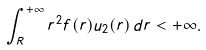<formula> <loc_0><loc_0><loc_500><loc_500>\int _ { R } ^ { + \infty } r ^ { 2 } f ( r ) u _ { 2 } ( r ) \, d r < + \infty .</formula> 